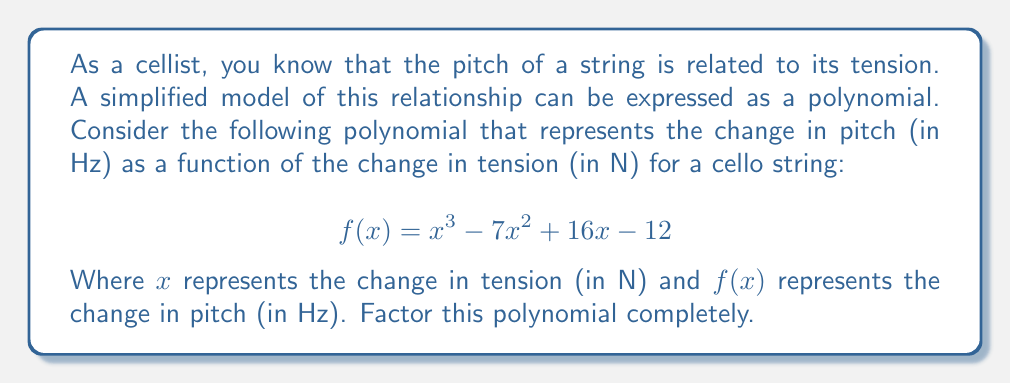Show me your answer to this math problem. To factor this polynomial, we'll follow these steps:

1) First, let's check if there are any rational roots using the rational root theorem. The possible rational roots are the factors of the constant term: ±1, ±2, ±3, ±4, ±6, ±12.

2) Testing these values, we find that $f(1) = 0$. So $(x-1)$ is a factor.

3) We can use polynomial long division to divide $f(x)$ by $(x-1)$:

   $$\frac{x^3 - 7x^2 + 16x - 12}{x-1} = x^2 - 6x + 10$$

4) Now we have: $f(x) = (x-1)(x^2 - 6x + 10)$

5) The quadratic factor $x^2 - 6x + 10$ can be factored further using the quadratic formula or by recognizing it as a difference of squares:

   $x^2 - 6x + 10 = (x-3)^2 + 1 = (x-3+i)(x-3-i)$

6) Therefore, the complete factorization is:

   $$f(x) = (x-1)(x-3+i)(x-3-i)$$

This factorization shows that the polynomial has one real root at $x=1$ and two complex roots at $x=3±i$.
Answer: $f(x) = (x-1)(x-3+i)(x-3-i)$ 